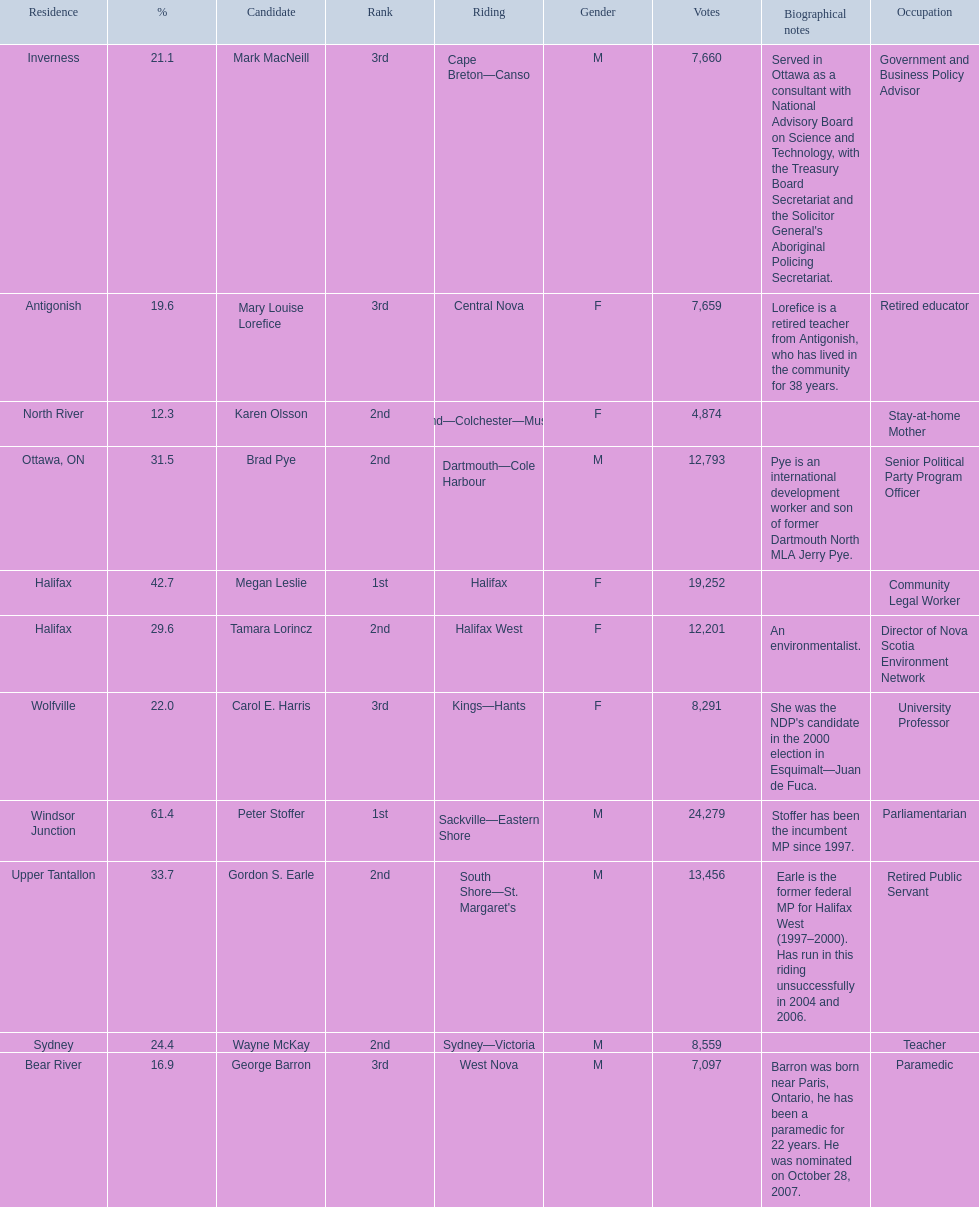How many votes did macneill receive? 7,660. How many votes did olsoon receive? 4,874. Between macneil and olsson, who received more votes? Mark MacNeill. 